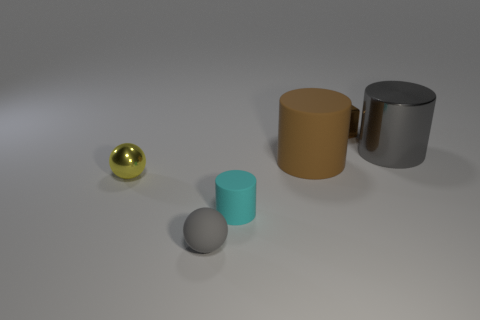There is a gray thing to the left of the matte cylinder behind the tiny yellow shiny ball; how big is it?
Give a very brief answer. Small. What material is the brown thing that is the same size as the gray shiny cylinder?
Provide a short and direct response. Rubber. Are there any small yellow spheres in front of the big gray metallic object?
Keep it short and to the point. Yes. Is the number of cyan cylinders that are behind the small brown cube the same as the number of yellow metallic balls?
Provide a short and direct response. No. What shape is the rubber thing that is the same size as the gray cylinder?
Ensure brevity in your answer.  Cylinder. What is the material of the block?
Your answer should be compact. Metal. What is the color of the thing that is both in front of the tiny brown thing and behind the big rubber cylinder?
Ensure brevity in your answer.  Gray. Is the number of cyan matte cylinders that are behind the large metallic cylinder the same as the number of objects on the right side of the cyan matte cylinder?
Offer a terse response. No. There is a small sphere that is the same material as the large gray thing; what color is it?
Your answer should be very brief. Yellow. There is a big shiny cylinder; is its color the same as the tiny sphere that is in front of the yellow sphere?
Your answer should be compact. Yes. 